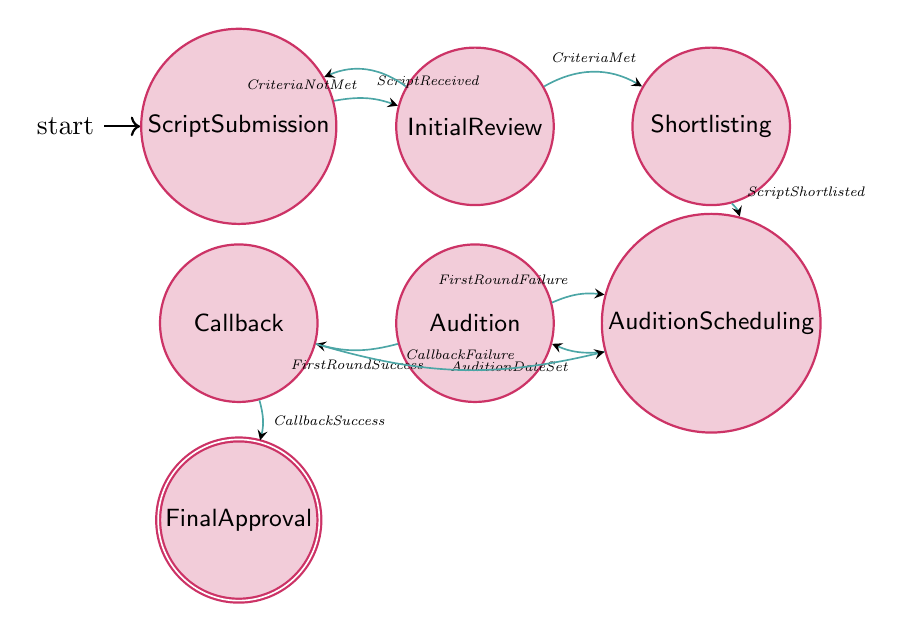What is the starting state of the process? The starting state is "Script Submission," indicated by the initial arrow pointing towards it.
Answer: Script Submission How many total states are present in the diagram? There are a total of 7 states in the diagram: Script Submission, Initial Review, Shortlisting, Audition Scheduling, Audition, Callback, and Final Approval.
Answer: 7 What must occur after the "Initial Review" if the criteria are met? If the criteria are met, the transition labeled "CriteriaMet" leads to the "Shortlisting" state, indicating the next step in the process.
Answer: Shortlisting What trigger causes the transition from "Audition" to "Callback"? The transition from "Audition" to "Callback" is triggered by a successful first-round audition, indicated by the label "FirstRoundSuccess."
Answer: FirstRoundSuccess If a script fails in the "Audition," what is the next state? If the script fails in the "Audition" state, the transition labeled "FirstRoundFailure" directs back to "Audition Scheduling," indicating the need to reschedule.
Answer: Audition Scheduling What is the final state of the process? The final state is "Final Approval," reached after a successful callback transition.
Answer: Final Approval Which state allows scheduling of auditions? The state where auditions are scheduled is called "Audition Scheduling," following the shortlisting of scripts.
Answer: Audition Scheduling What must happen for a script to move from "Shortlisting" to "Audition Scheduling"? For a script to move from "Shortlisting" to "Audition Scheduling," the transition must be triggered by the label "ScriptShortlisted."
Answer: ScriptShortlisted 